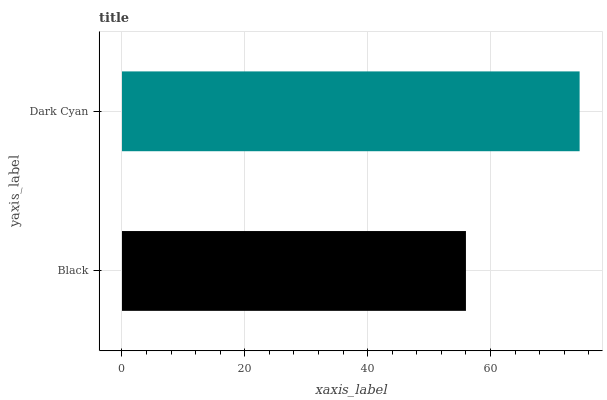Is Black the minimum?
Answer yes or no. Yes. Is Dark Cyan the maximum?
Answer yes or no. Yes. Is Dark Cyan the minimum?
Answer yes or no. No. Is Dark Cyan greater than Black?
Answer yes or no. Yes. Is Black less than Dark Cyan?
Answer yes or no. Yes. Is Black greater than Dark Cyan?
Answer yes or no. No. Is Dark Cyan less than Black?
Answer yes or no. No. Is Dark Cyan the high median?
Answer yes or no. Yes. Is Black the low median?
Answer yes or no. Yes. Is Black the high median?
Answer yes or no. No. Is Dark Cyan the low median?
Answer yes or no. No. 